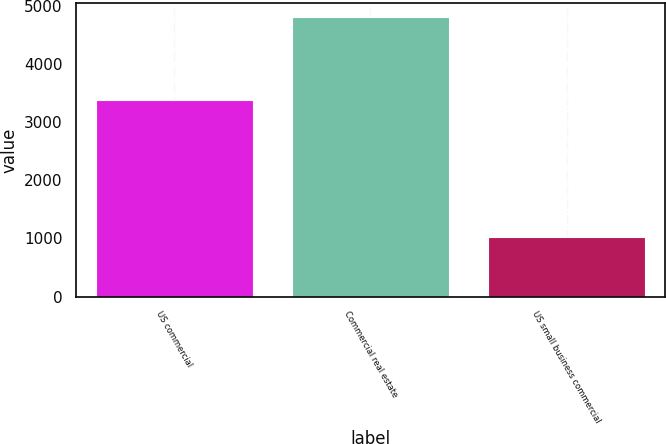<chart> <loc_0><loc_0><loc_500><loc_500><bar_chart><fcel>US commercial<fcel>Commercial real estate<fcel>US small business commercial<nl><fcel>3389<fcel>4813<fcel>1028<nl></chart> 